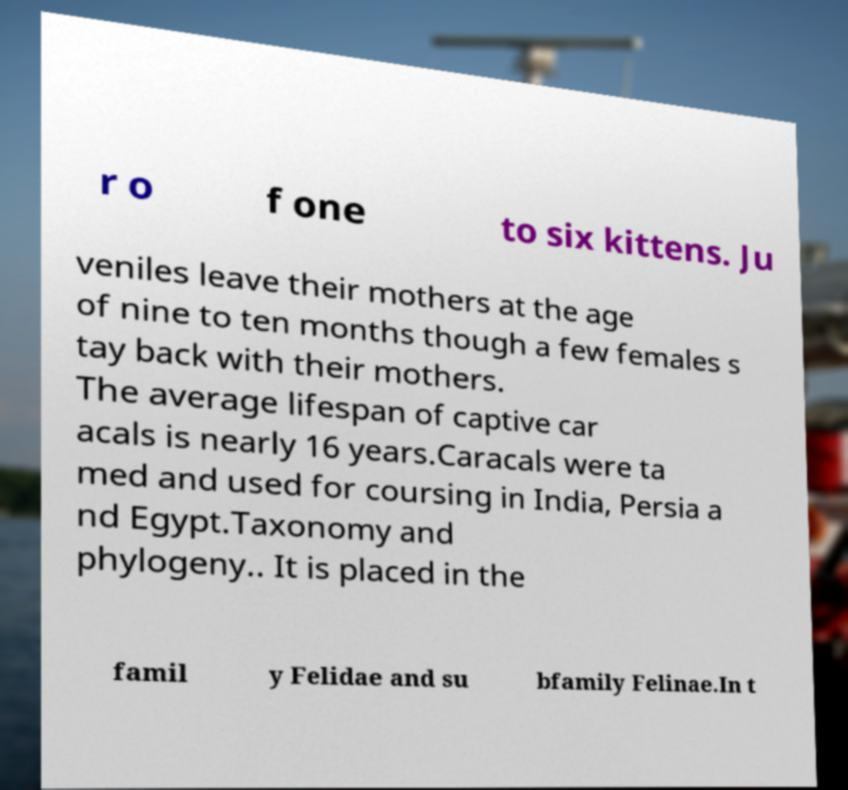Can you read and provide the text displayed in the image?This photo seems to have some interesting text. Can you extract and type it out for me? r o f one to six kittens. Ju veniles leave their mothers at the age of nine to ten months though a few females s tay back with their mothers. The average lifespan of captive car acals is nearly 16 years.Caracals were ta med and used for coursing in India, Persia a nd Egypt.Taxonomy and phylogeny.. It is placed in the famil y Felidae and su bfamily Felinae.In t 